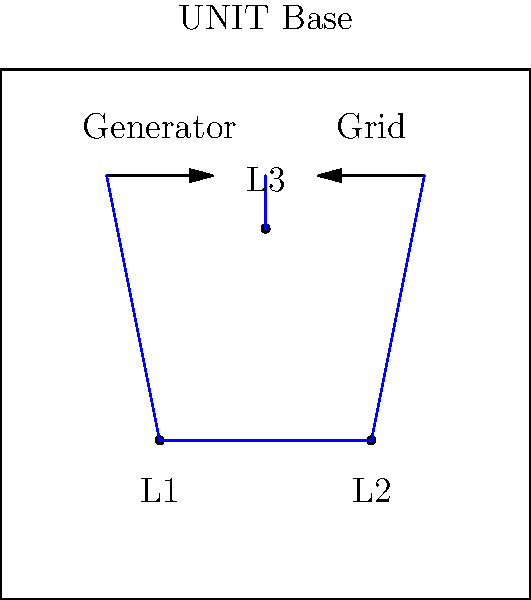As a comic book artist for Doctor Who spin-offs, you're tasked with illustrating a UNIT base power distribution network. The base has two power sources: a local generator and a connection to the main power grid. There are three load points (L1, L2, L3) within the base. If the total power demand is 150 kVA and the power factor is 0.8 lagging, what is the reactive power demand in kVAR? To solve this problem, we'll follow these steps:

1. Understand the given information:
   - Total power demand (S) = 150 kVA
   - Power factor (cos φ) = 0.8 lagging

2. Calculate the active power (P):
   $P = S \times \cos \phi$
   $P = 150 \text{ kVA} \times 0.8 = 120 \text{ kW}$

3. Use the power triangle to find the reactive power (Q):
   $S^2 = P^2 + Q^2$

4. Rearrange the equation to solve for Q:
   $Q^2 = S^2 - P^2$
   $Q = \sqrt{S^2 - P^2}$

5. Substitute the values:
   $Q = \sqrt{150^2 - 120^2}$
   $Q = \sqrt{22500 - 14400}$
   $Q = \sqrt{8100}$
   $Q = 90 \text{ kVAR}$

The reactive power demand is 90 kVAR.
Answer: 90 kVAR 